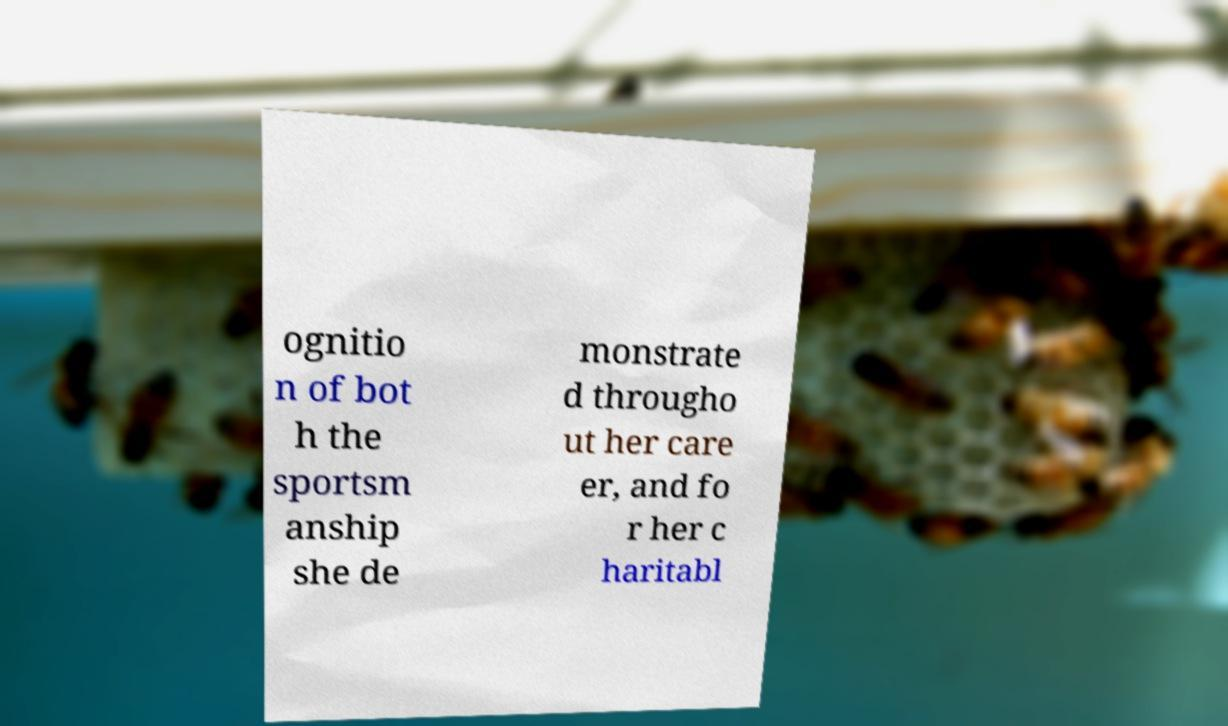What messages or text are displayed in this image? I need them in a readable, typed format. ognitio n of bot h the sportsm anship she de monstrate d througho ut her care er, and fo r her c haritabl 